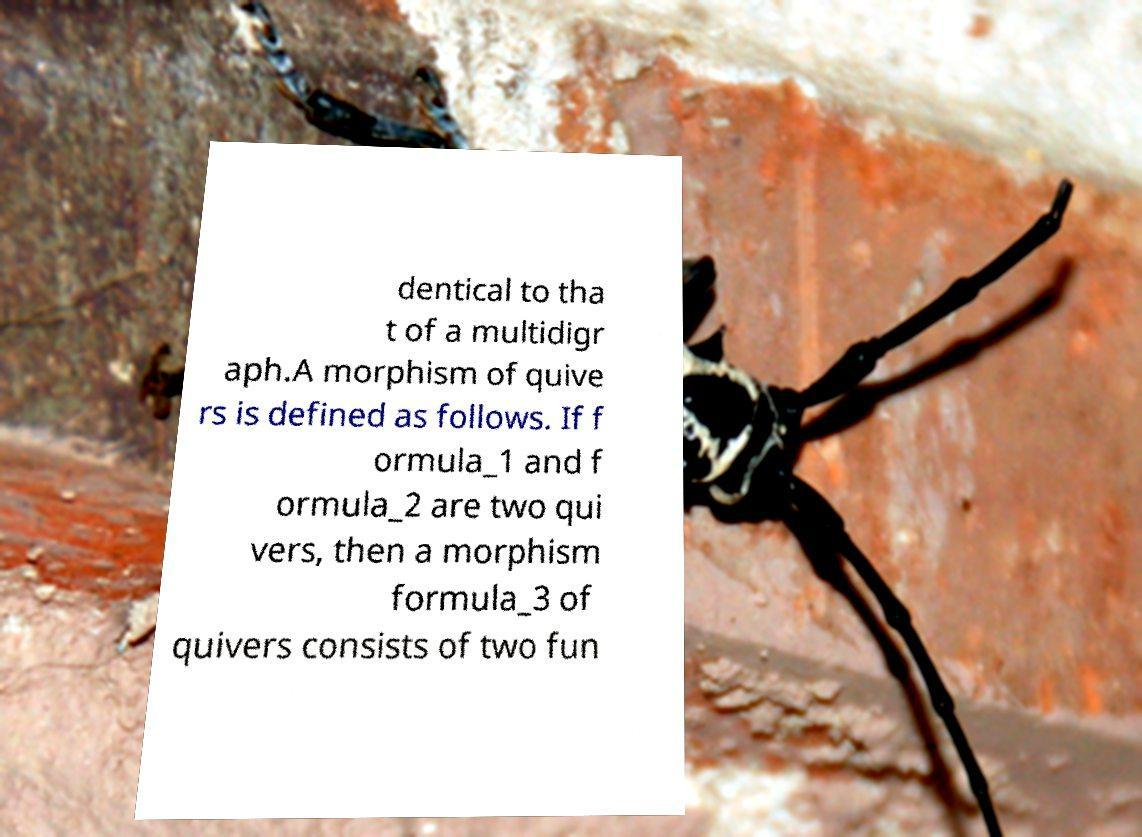Please identify and transcribe the text found in this image. dentical to tha t of a multidigr aph.A morphism of quive rs is defined as follows. If f ormula_1 and f ormula_2 are two qui vers, then a morphism formula_3 of quivers consists of two fun 